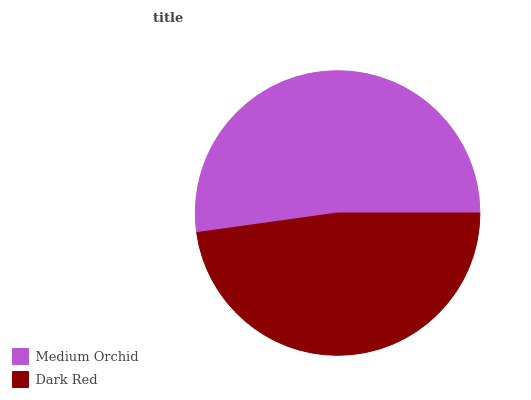Is Dark Red the minimum?
Answer yes or no. Yes. Is Medium Orchid the maximum?
Answer yes or no. Yes. Is Dark Red the maximum?
Answer yes or no. No. Is Medium Orchid greater than Dark Red?
Answer yes or no. Yes. Is Dark Red less than Medium Orchid?
Answer yes or no. Yes. Is Dark Red greater than Medium Orchid?
Answer yes or no. No. Is Medium Orchid less than Dark Red?
Answer yes or no. No. Is Medium Orchid the high median?
Answer yes or no. Yes. Is Dark Red the low median?
Answer yes or no. Yes. Is Dark Red the high median?
Answer yes or no. No. Is Medium Orchid the low median?
Answer yes or no. No. 